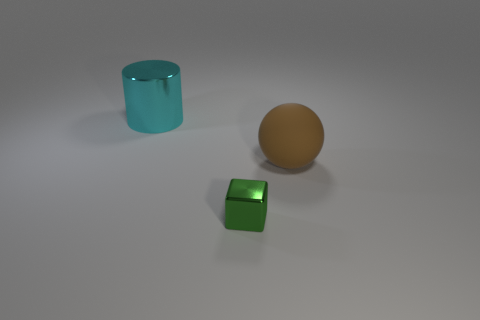Are there fewer small green metallic things that are to the right of the large brown rubber object than large balls on the right side of the tiny metal thing? Yes, upon examining the image, there appears to be just one small green metallic object to the right of the large brown sphere, while there are no large balls on the right side of the tiny metal cube. So there are indeed fewer small green metallic things than large balls as described in your question. 